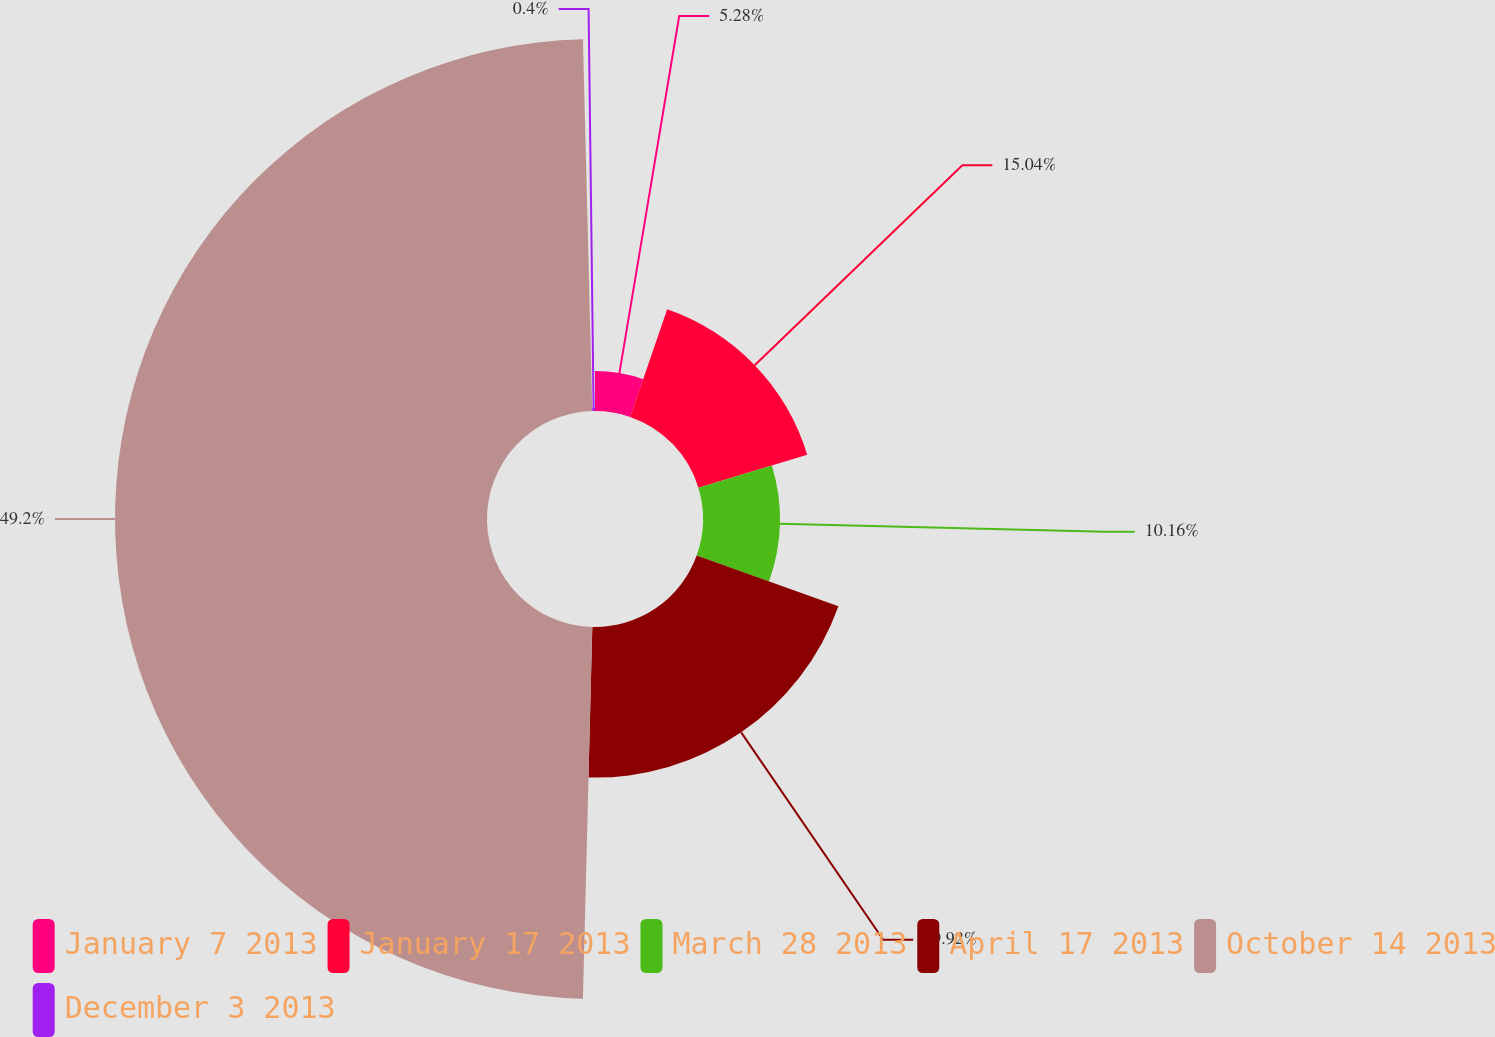Convert chart to OTSL. <chart><loc_0><loc_0><loc_500><loc_500><pie_chart><fcel>January 7 2013<fcel>January 17 2013<fcel>March 28 2013<fcel>April 17 2013<fcel>October 14 2013<fcel>December 3 2013<nl><fcel>5.28%<fcel>15.04%<fcel>10.16%<fcel>19.92%<fcel>49.2%<fcel>0.4%<nl></chart> 